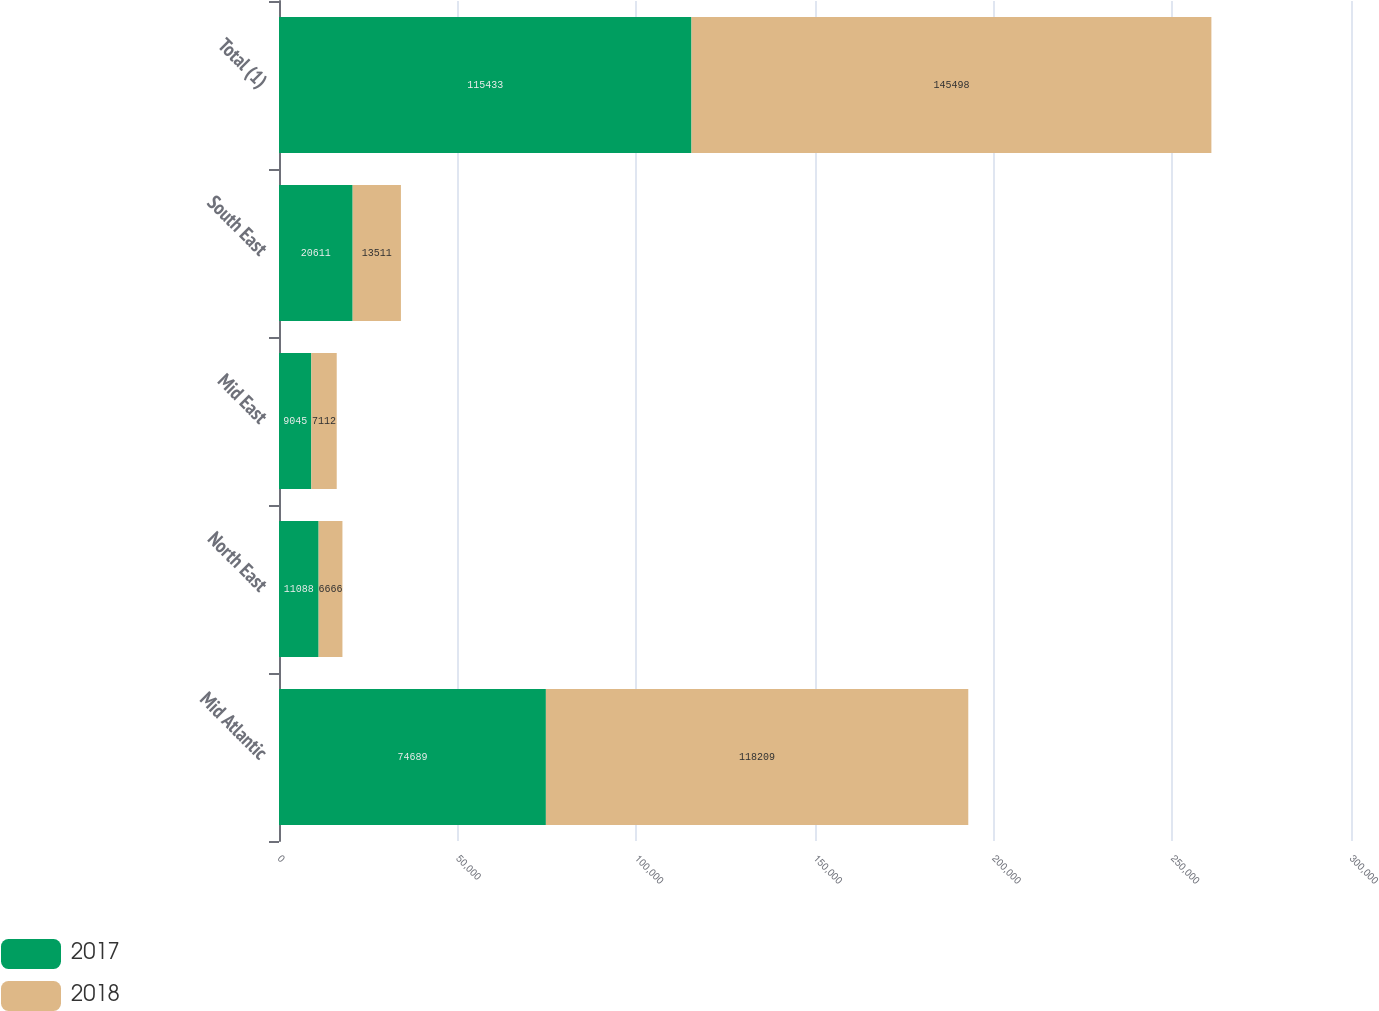Convert chart to OTSL. <chart><loc_0><loc_0><loc_500><loc_500><stacked_bar_chart><ecel><fcel>Mid Atlantic<fcel>North East<fcel>Mid East<fcel>South East<fcel>Total (1)<nl><fcel>2017<fcel>74689<fcel>11088<fcel>9045<fcel>20611<fcel>115433<nl><fcel>2018<fcel>118209<fcel>6666<fcel>7112<fcel>13511<fcel>145498<nl></chart> 